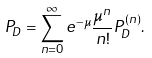<formula> <loc_0><loc_0><loc_500><loc_500>P _ { D } = \sum _ { n = 0 } ^ { \infty } e ^ { - \mu } \frac { \mu ^ { n } } { n ! } P _ { D } ^ { ( n ) } .</formula> 